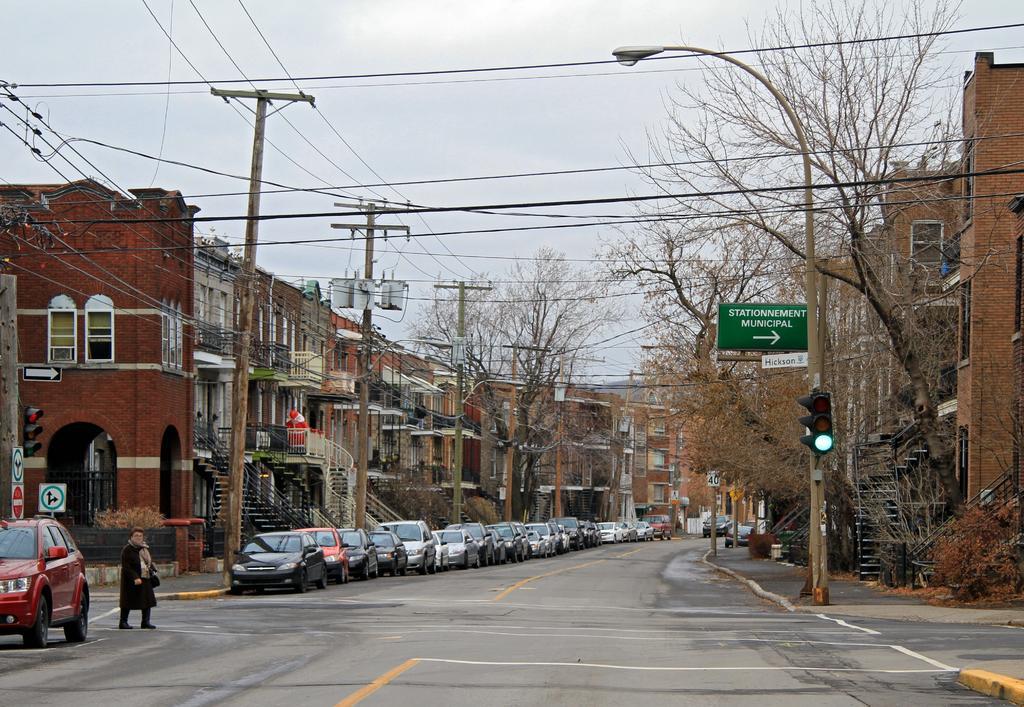How would you summarize this image in a sentence or two? In this image I can see fleets of cars and a person on the road. In the background I can see buildings, wires, poles, trees, boards and a staircase. At the top I can see the sky. This image is taken on the road. 